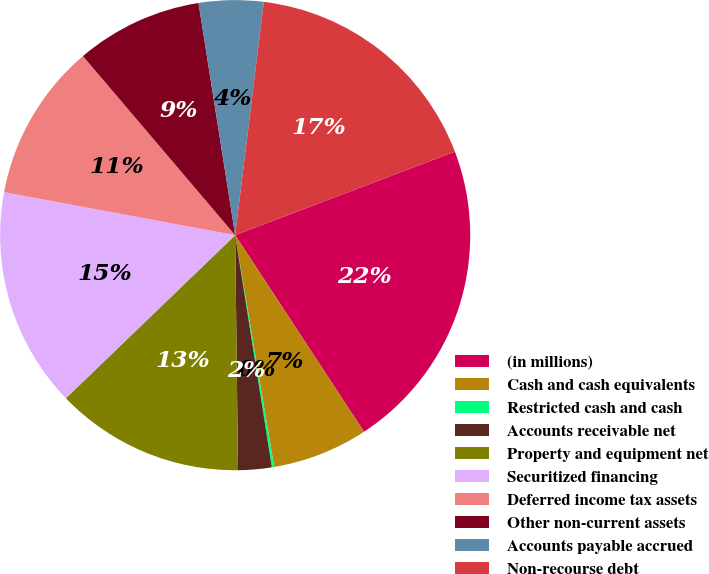Convert chart. <chart><loc_0><loc_0><loc_500><loc_500><pie_chart><fcel>(in millions)<fcel>Cash and cash equivalents<fcel>Restricted cash and cash<fcel>Accounts receivable net<fcel>Property and equipment net<fcel>Securitized financing<fcel>Deferred income tax assets<fcel>Other non-current assets<fcel>Accounts payable accrued<fcel>Non-recourse debt<nl><fcel>21.55%<fcel>6.58%<fcel>0.16%<fcel>2.3%<fcel>12.99%<fcel>15.13%<fcel>10.86%<fcel>8.72%<fcel>4.44%<fcel>17.27%<nl></chart> 